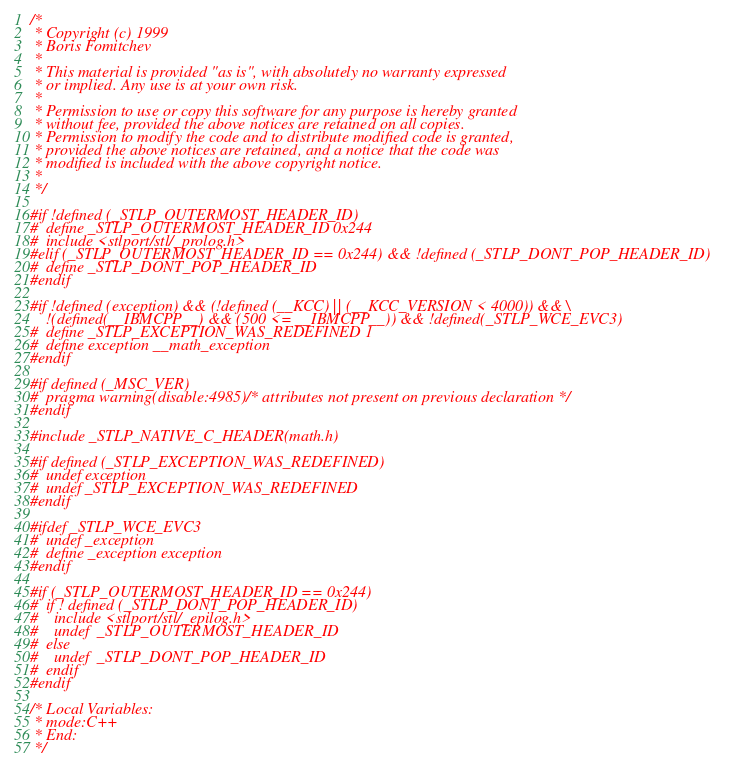<code> <loc_0><loc_0><loc_500><loc_500><_C_>/*
 * Copyright (c) 1999
 * Boris Fomitchev
 *
 * This material is provided "as is", with absolutely no warranty expressed
 * or implied. Any use is at your own risk.
 *
 * Permission to use or copy this software for any purpose is hereby granted
 * without fee, provided the above notices are retained on all copies.
 * Permission to modify the code and to distribute modified code is granted,
 * provided the above notices are retained, and a notice that the code was
 * modified is included with the above copyright notice.
 *
 */

#if !defined (_STLP_OUTERMOST_HEADER_ID)
#  define _STLP_OUTERMOST_HEADER_ID 0x244
#  include <stlport/stl/_prolog.h>
#elif (_STLP_OUTERMOST_HEADER_ID == 0x244) && !defined (_STLP_DONT_POP_HEADER_ID)
#  define _STLP_DONT_POP_HEADER_ID
#endif

#if !defined (exception) && (!defined (__KCC) || (__KCC_VERSION < 4000)) && \
    !(defined(__IBMCPP__) && (500 <= __IBMCPP__)) && !defined(_STLP_WCE_EVC3)
#  define _STLP_EXCEPTION_WAS_REDEFINED 1
#  define exception __math_exception
#endif

#if defined (_MSC_VER)
#  pragma warning(disable:4985) /* attributes not present on previous declaration */
#endif

#include _STLP_NATIVE_C_HEADER(math.h)

#if defined (_STLP_EXCEPTION_WAS_REDEFINED)
#  undef exception
#  undef _STLP_EXCEPTION_WAS_REDEFINED
#endif

#ifdef _STLP_WCE_EVC3
#  undef _exception
#  define _exception exception
#endif

#if (_STLP_OUTERMOST_HEADER_ID == 0x244)
#  if ! defined (_STLP_DONT_POP_HEADER_ID)
#    include <stlport/stl/_epilog.h>
#    undef  _STLP_OUTERMOST_HEADER_ID
#  else
#    undef  _STLP_DONT_POP_HEADER_ID
#  endif
#endif

/* Local Variables:
 * mode:C++
 * End:
 */
</code> 